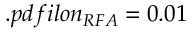<formula> <loc_0><loc_0><loc_500><loc_500>. p d f i l o n _ { R F A } = 0 . 0 1</formula> 